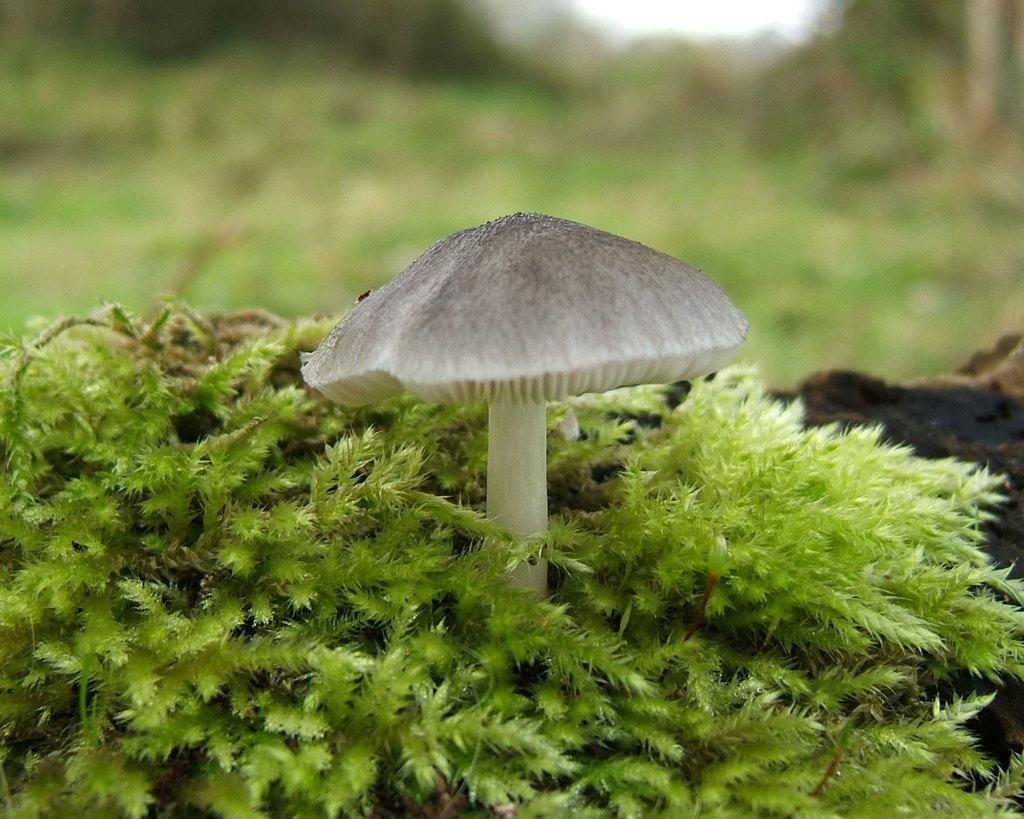What type of living organisms can be seen in the image? Plants and mushrooms can be seen in the image. What type of bell can be seen in the image? There is no bell present in the image. Is there a channel visible in the image? There is no channel visible in the image. How many houses are present in the image? There are no houses present in the image. 